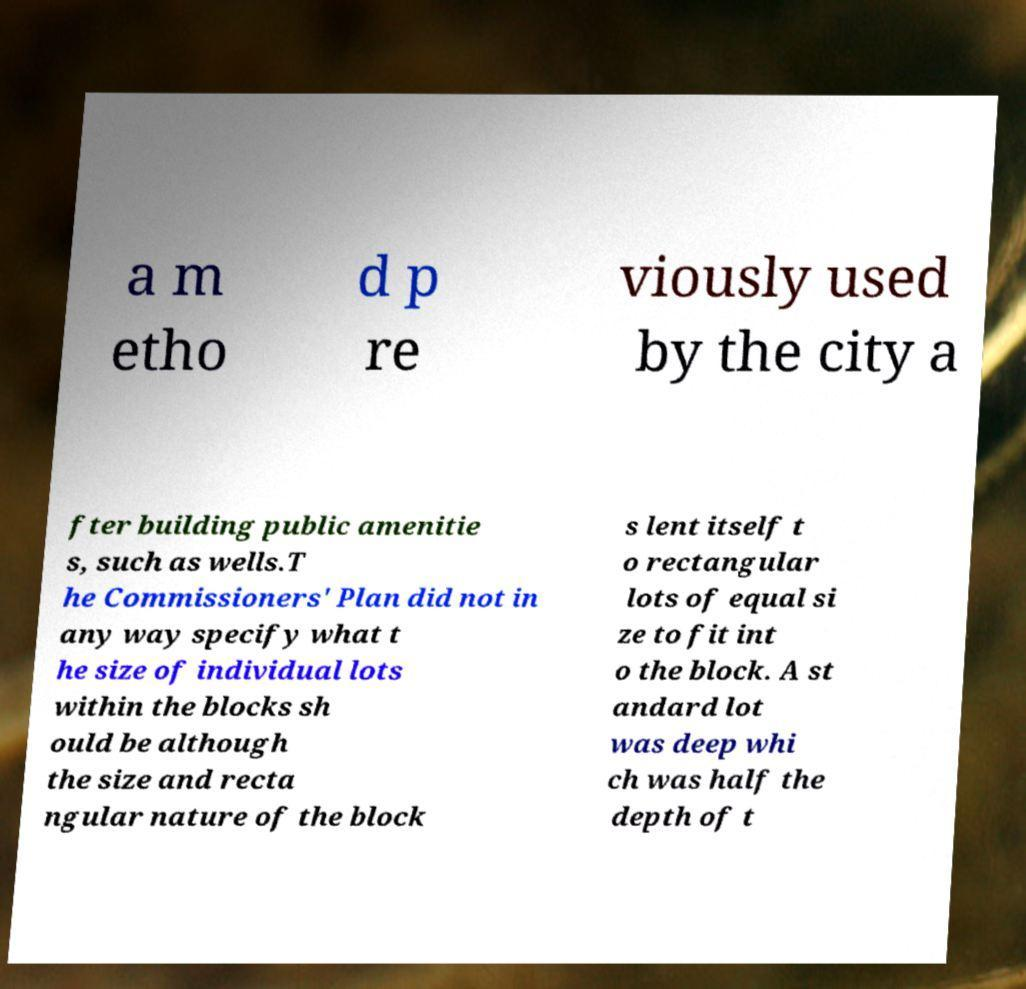Please read and relay the text visible in this image. What does it say? a m etho d p re viously used by the city a fter building public amenitie s, such as wells.T he Commissioners' Plan did not in any way specify what t he size of individual lots within the blocks sh ould be although the size and recta ngular nature of the block s lent itself t o rectangular lots of equal si ze to fit int o the block. A st andard lot was deep whi ch was half the depth of t 